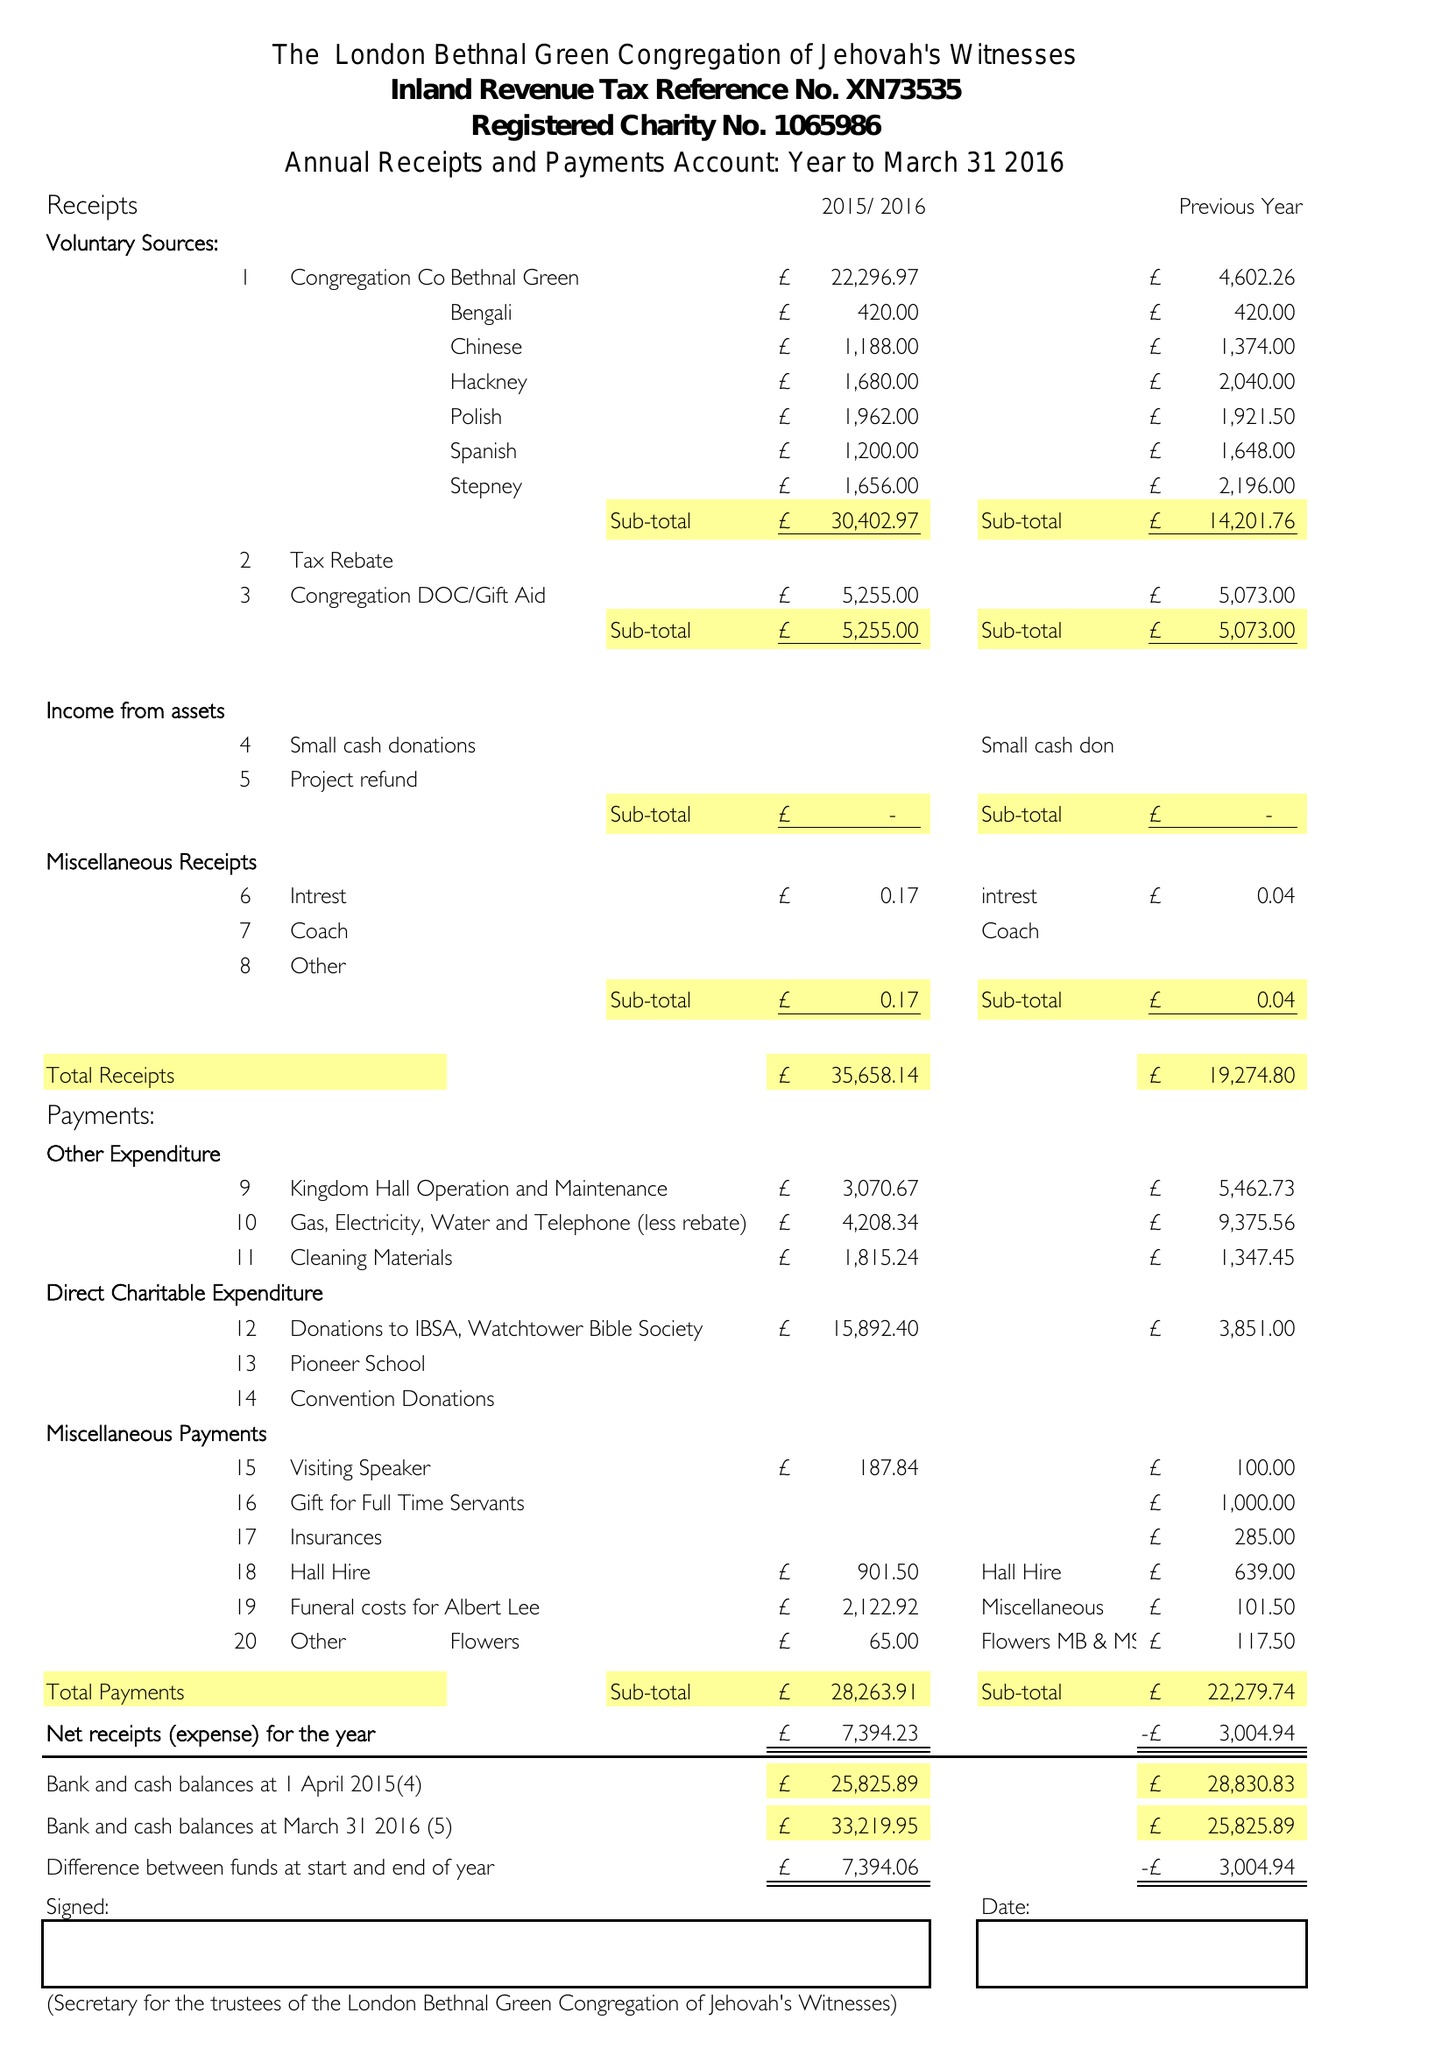What is the value for the address__post_town?
Answer the question using a single word or phrase. LONDON 